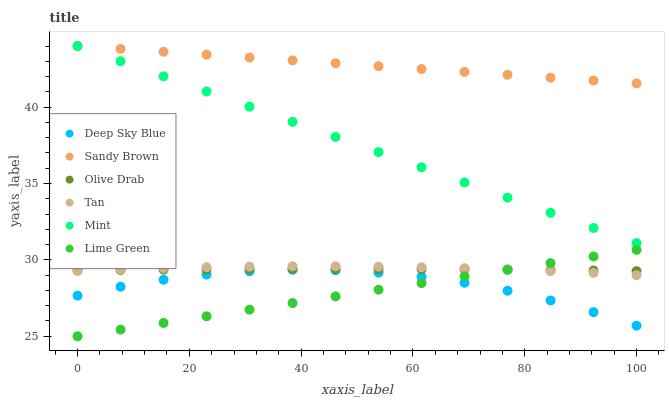Does Lime Green have the minimum area under the curve?
Answer yes or no. Yes. Does Sandy Brown have the maximum area under the curve?
Answer yes or no. Yes. Does Mint have the minimum area under the curve?
Answer yes or no. No. Does Mint have the maximum area under the curve?
Answer yes or no. No. Is Sandy Brown the smoothest?
Answer yes or no. Yes. Is Deep Sky Blue the roughest?
Answer yes or no. Yes. Is Mint the smoothest?
Answer yes or no. No. Is Mint the roughest?
Answer yes or no. No. Does Lime Green have the lowest value?
Answer yes or no. Yes. Does Mint have the lowest value?
Answer yes or no. No. Does Mint have the highest value?
Answer yes or no. Yes. Does Deep Sky Blue have the highest value?
Answer yes or no. No. Is Deep Sky Blue less than Mint?
Answer yes or no. Yes. Is Olive Drab greater than Deep Sky Blue?
Answer yes or no. Yes. Does Olive Drab intersect Lime Green?
Answer yes or no. Yes. Is Olive Drab less than Lime Green?
Answer yes or no. No. Is Olive Drab greater than Lime Green?
Answer yes or no. No. Does Deep Sky Blue intersect Mint?
Answer yes or no. No. 